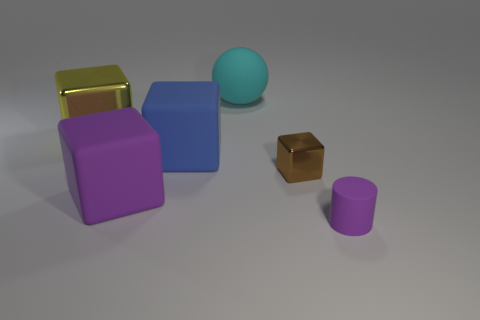Add 4 small blue cylinders. How many objects exist? 10 Subtract all cylinders. How many objects are left? 5 Subtract all large blue cubes. Subtract all blue things. How many objects are left? 4 Add 4 brown metallic blocks. How many brown metallic blocks are left? 5 Add 1 cyan things. How many cyan things exist? 2 Subtract 0 red blocks. How many objects are left? 6 